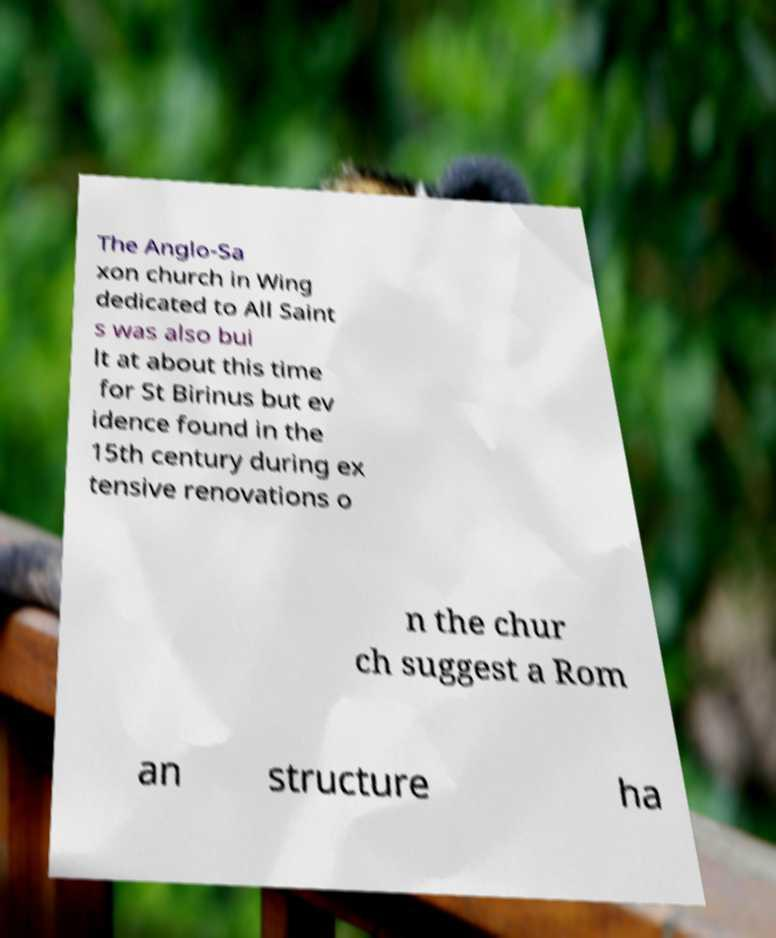For documentation purposes, I need the text within this image transcribed. Could you provide that? The Anglo-Sa xon church in Wing dedicated to All Saint s was also bui lt at about this time for St Birinus but ev idence found in the 15th century during ex tensive renovations o n the chur ch suggest a Rom an structure ha 